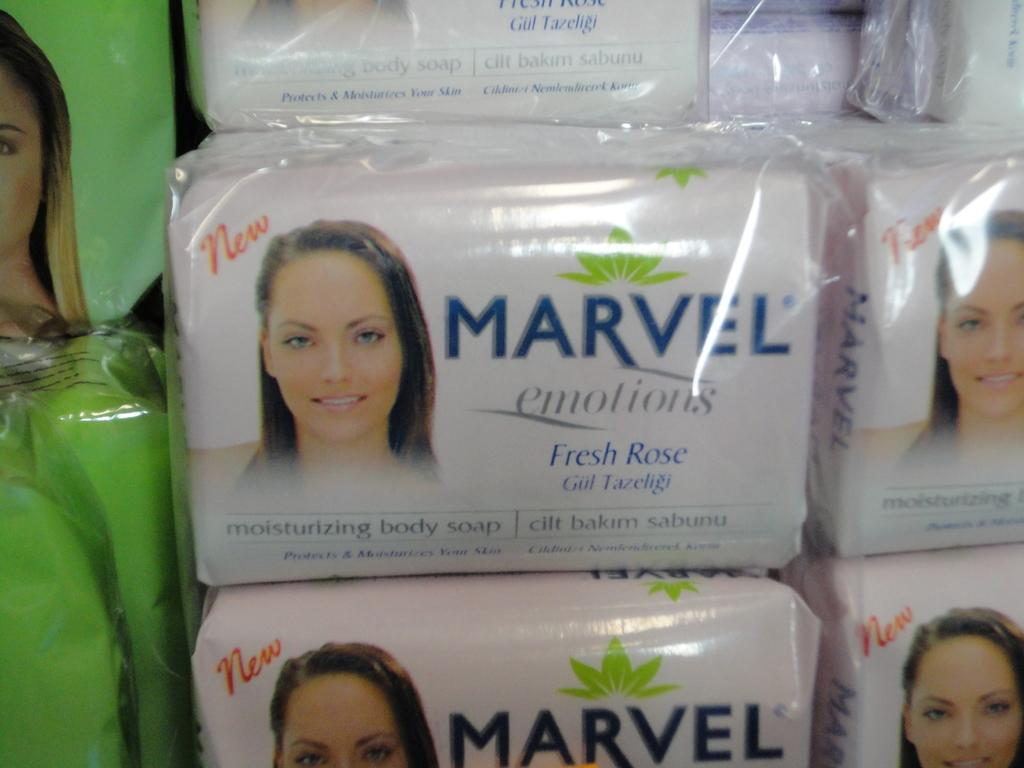What is the color of the objects in the image? The objects in the image are white in color. What is written on the white color objects? The white color objects have Marvel emotions written on them. What type of weather can be seen in the image? There is no indication of weather in the image, as it features white color objects with Marvel emotions written on them. What type of authority is depicted in the image? There is no depiction of authority in the image; it only features white color objects with Marvel emotions written on them. 